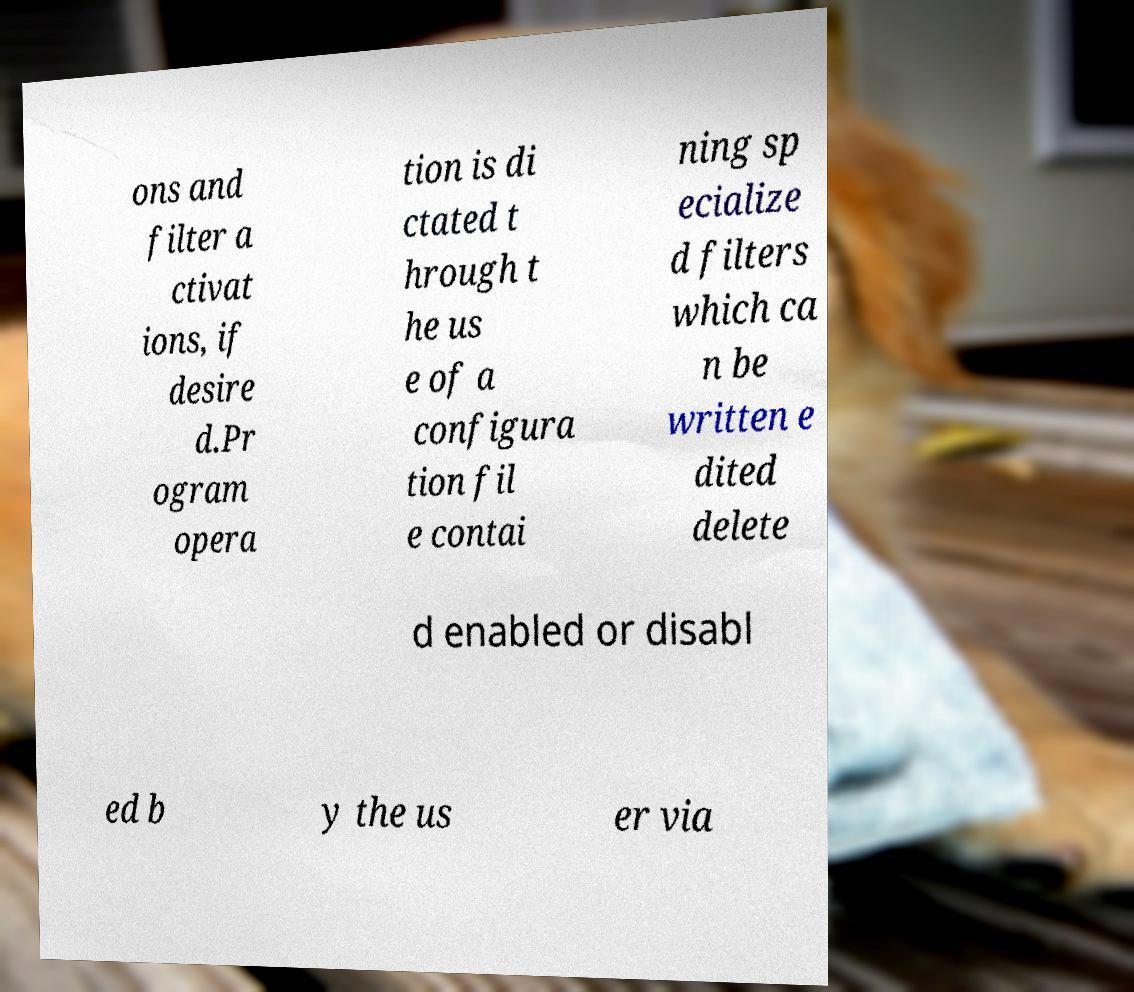Please identify and transcribe the text found in this image. ons and filter a ctivat ions, if desire d.Pr ogram opera tion is di ctated t hrough t he us e of a configura tion fil e contai ning sp ecialize d filters which ca n be written e dited delete d enabled or disabl ed b y the us er via 